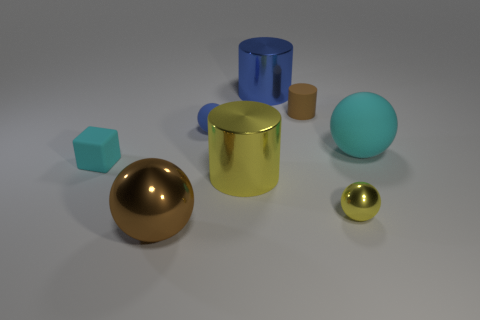Add 1 blue metallic things. How many objects exist? 9 Subtract all cubes. How many objects are left? 7 Subtract all cylinders. Subtract all small blue objects. How many objects are left? 4 Add 3 tiny cyan rubber things. How many tiny cyan rubber things are left? 4 Add 5 small blocks. How many small blocks exist? 6 Subtract 0 purple cylinders. How many objects are left? 8 